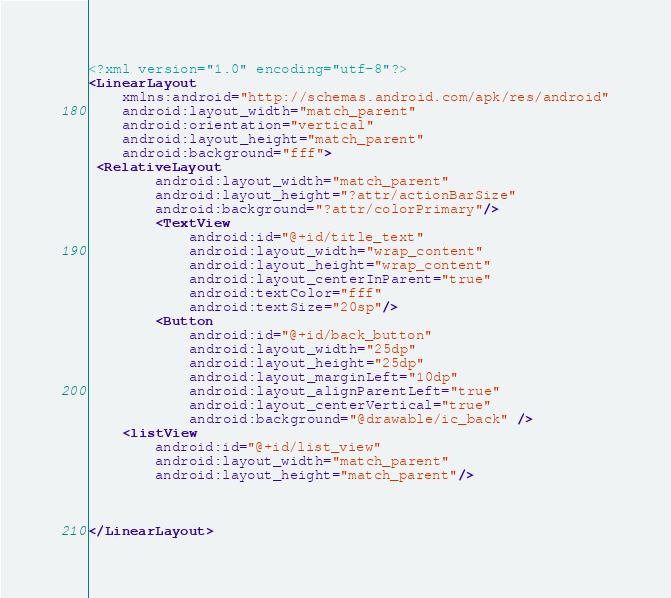Convert code to text. <code><loc_0><loc_0><loc_500><loc_500><_XML_><?xml version="1.0" encoding="utf-8"?>
<LinearLayout
    xmlns:android="http://schemas.android.com/apk/res/android"
    android:layout_width="match_parent"
    android:orientation="vertical"
    android:layout_height="match_parent"
    android:background="fff">
 <RelativeLayout
        android:layout_width="match_parent"
        android:layout_height="?attr/actionBarSize"
        android:background="?attr/colorPrimary"/>
        <TextView
            android:id="@+id/title_text"
            android:layout_width="wrap_content"
            android:layout_height="wrap_content"
            android:layout_centerInParent="true"
            android:textColor="fff"
            android:textSize="20sp"/>
        <Button
            android:id="@+id/back_button"
            android:layout_width="25dp"
            android:layout_height="25dp"
            android:layout_marginLeft="10dp"
            android:layout_alignParentLeft="true"
            android:layout_centerVertical="true"
            android:background="@drawable/ic_back" />
    <listView
        android:id="@+id/list_view"
        android:layout_width="match_parent"
        android:layout_height="match_parent"/>



</LinearLayout></code> 